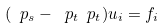<formula> <loc_0><loc_0><loc_500><loc_500>( \ p _ { s } - \ p _ { t } \ p _ { t } ) u _ { i } = f _ { i }</formula> 